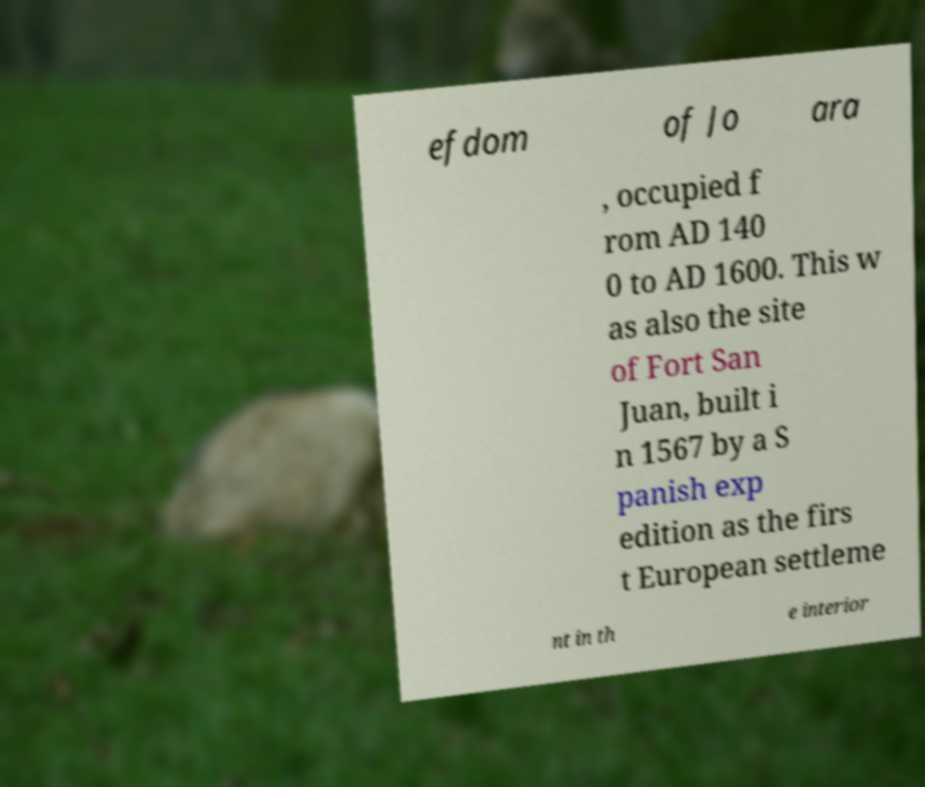I need the written content from this picture converted into text. Can you do that? efdom of Jo ara , occupied f rom AD 140 0 to AD 1600. This w as also the site of Fort San Juan, built i n 1567 by a S panish exp edition as the firs t European settleme nt in th e interior 